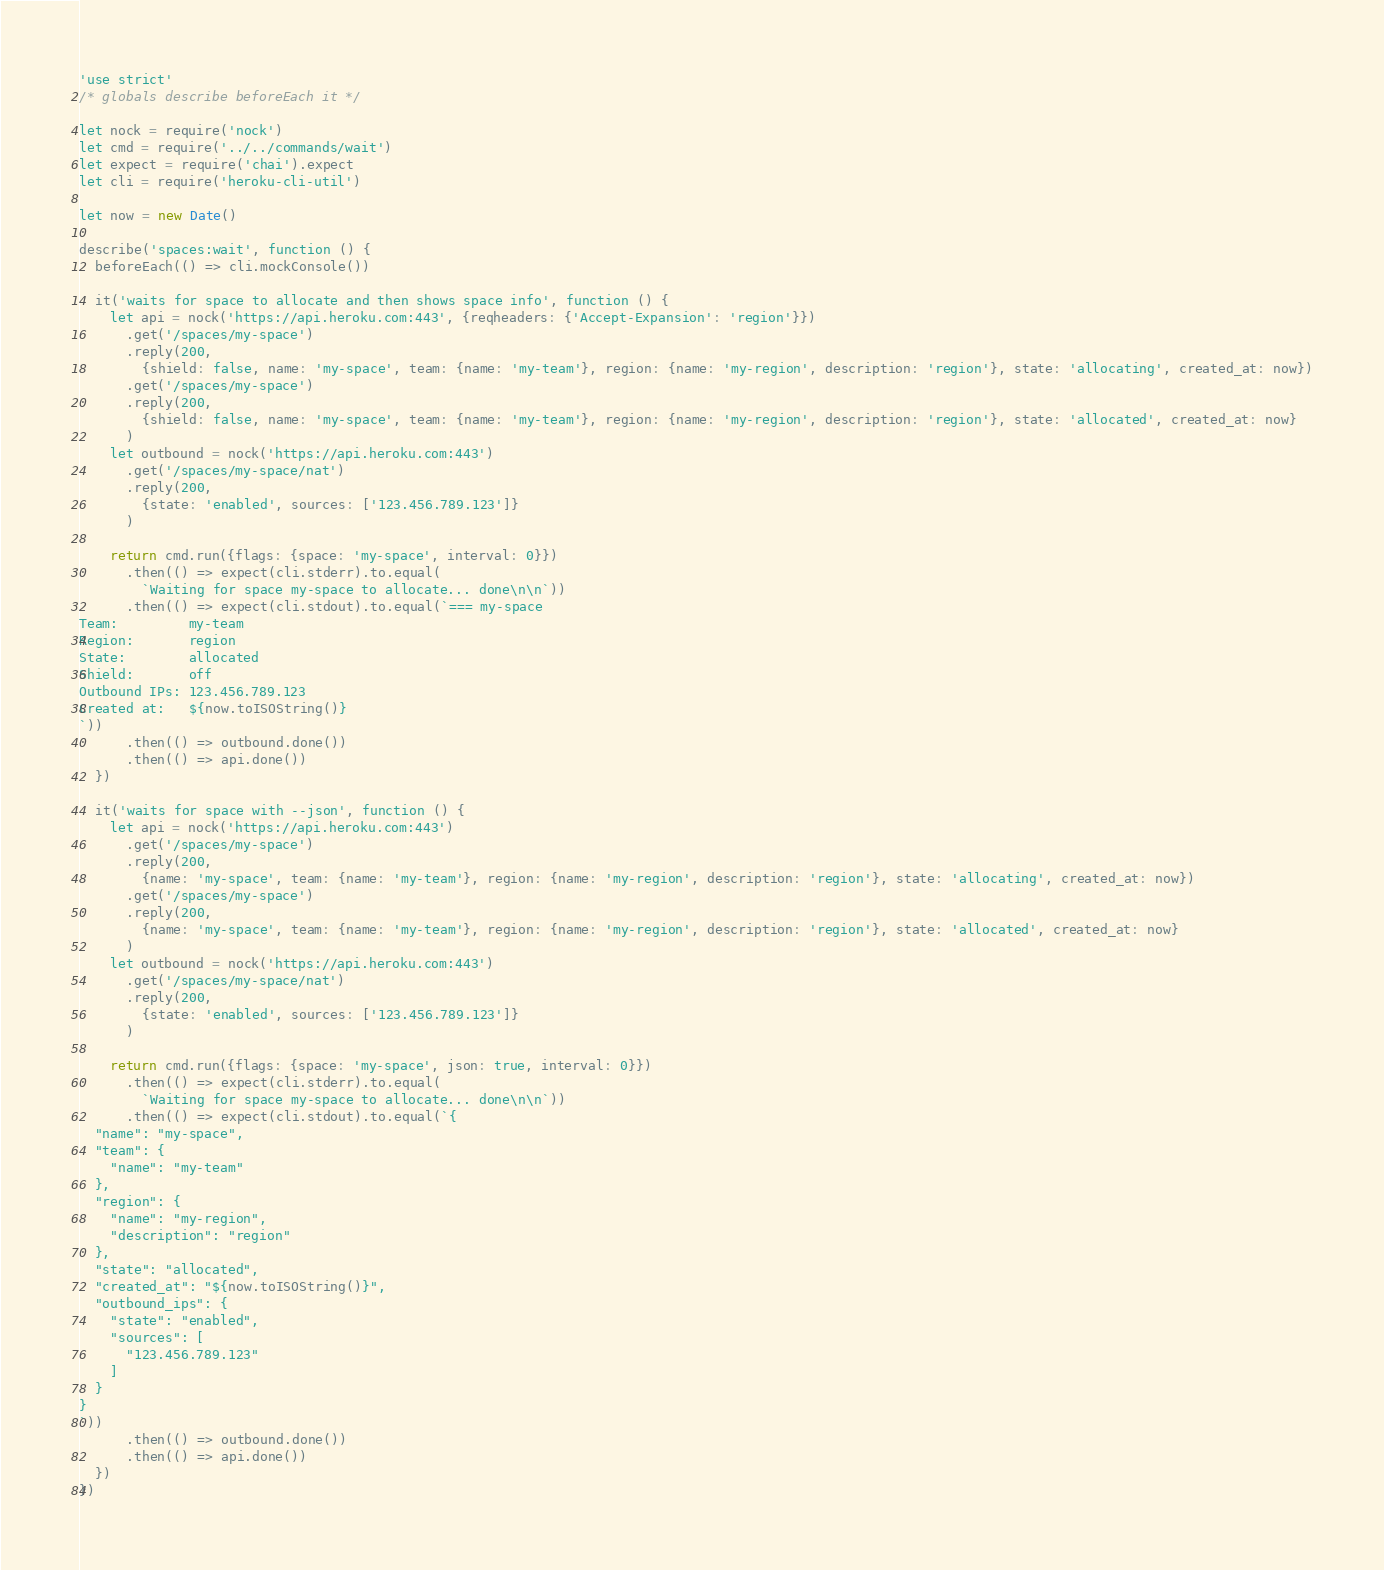Convert code to text. <code><loc_0><loc_0><loc_500><loc_500><_JavaScript_>'use strict'
/* globals describe beforeEach it */

let nock = require('nock')
let cmd = require('../../commands/wait')
let expect = require('chai').expect
let cli = require('heroku-cli-util')

let now = new Date()

describe('spaces:wait', function () {
  beforeEach(() => cli.mockConsole())

  it('waits for space to allocate and then shows space info', function () {
    let api = nock('https://api.heroku.com:443', {reqheaders: {'Accept-Expansion': 'region'}})
      .get('/spaces/my-space')
      .reply(200,
        {shield: false, name: 'my-space', team: {name: 'my-team'}, region: {name: 'my-region', description: 'region'}, state: 'allocating', created_at: now})
      .get('/spaces/my-space')
      .reply(200,
        {shield: false, name: 'my-space', team: {name: 'my-team'}, region: {name: 'my-region', description: 'region'}, state: 'allocated', created_at: now}
      )
    let outbound = nock('https://api.heroku.com:443')
      .get('/spaces/my-space/nat')
      .reply(200,
        {state: 'enabled', sources: ['123.456.789.123']}
      )

    return cmd.run({flags: {space: 'my-space', interval: 0}})
      .then(() => expect(cli.stderr).to.equal(
        `Waiting for space my-space to allocate... done\n\n`))
      .then(() => expect(cli.stdout).to.equal(`=== my-space
Team:         my-team
Region:       region
State:        allocated
Shield:       off
Outbound IPs: 123.456.789.123
Created at:   ${now.toISOString()}
`))
      .then(() => outbound.done())
      .then(() => api.done())
  })

  it('waits for space with --json', function () {
    let api = nock('https://api.heroku.com:443')
      .get('/spaces/my-space')
      .reply(200,
        {name: 'my-space', team: {name: 'my-team'}, region: {name: 'my-region', description: 'region'}, state: 'allocating', created_at: now})
      .get('/spaces/my-space')
      .reply(200,
        {name: 'my-space', team: {name: 'my-team'}, region: {name: 'my-region', description: 'region'}, state: 'allocated', created_at: now}
      )
    let outbound = nock('https://api.heroku.com:443')
      .get('/spaces/my-space/nat')
      .reply(200,
        {state: 'enabled', sources: ['123.456.789.123']}
      )

    return cmd.run({flags: {space: 'my-space', json: true, interval: 0}})
      .then(() => expect(cli.stderr).to.equal(
        `Waiting for space my-space to allocate... done\n\n`))
      .then(() => expect(cli.stdout).to.equal(`{
  "name": "my-space",
  "team": {
    "name": "my-team"
  },
  "region": {
    "name": "my-region",
    "description": "region"
  },
  "state": "allocated",
  "created_at": "${now.toISOString()}",
  "outbound_ips": {
    "state": "enabled",
    "sources": [
      "123.456.789.123"
    ]
  }
}
`))
      .then(() => outbound.done())
      .then(() => api.done())
  })
})
</code> 